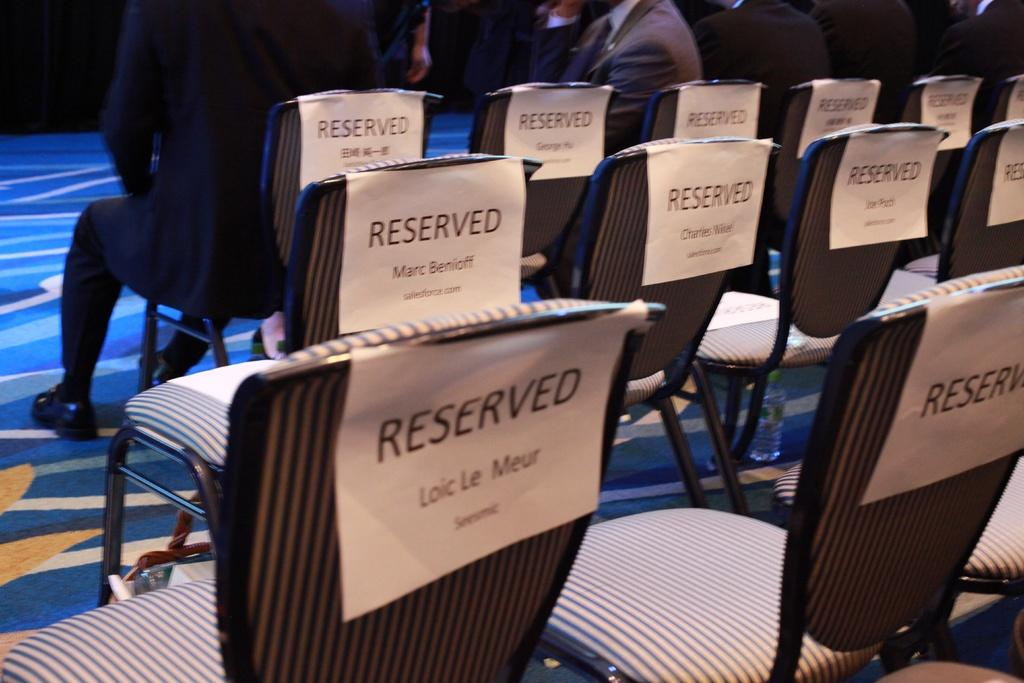<image>
Render a clear and concise summary of the photo. a bunch of seats with reserved on them 